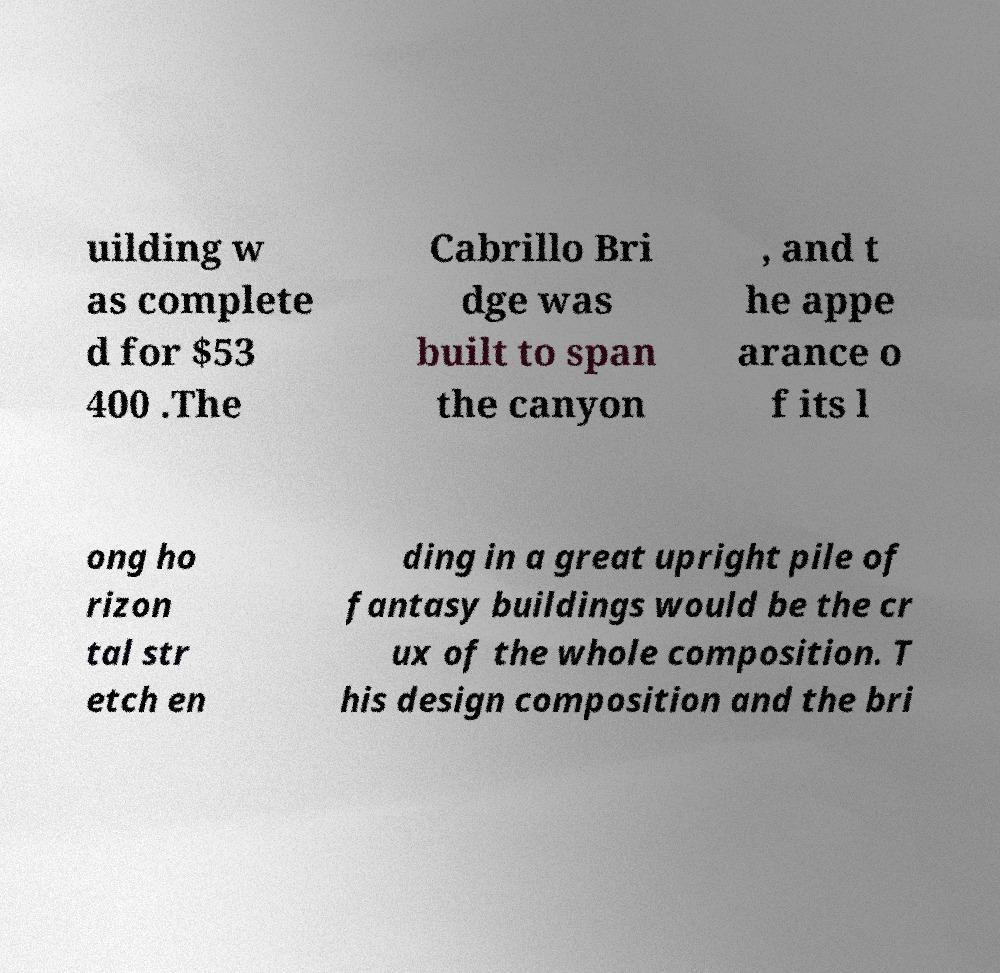There's text embedded in this image that I need extracted. Can you transcribe it verbatim? uilding w as complete d for $53 400 .The Cabrillo Bri dge was built to span the canyon , and t he appe arance o f its l ong ho rizon tal str etch en ding in a great upright pile of fantasy buildings would be the cr ux of the whole composition. T his design composition and the bri 